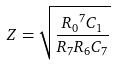Convert formula to latex. <formula><loc_0><loc_0><loc_500><loc_500>Z = \sqrt { \frac { { R _ { 0 } } ^ { 7 } C _ { 1 } } { R _ { 7 } R _ { 6 } C _ { 7 } } }</formula> 